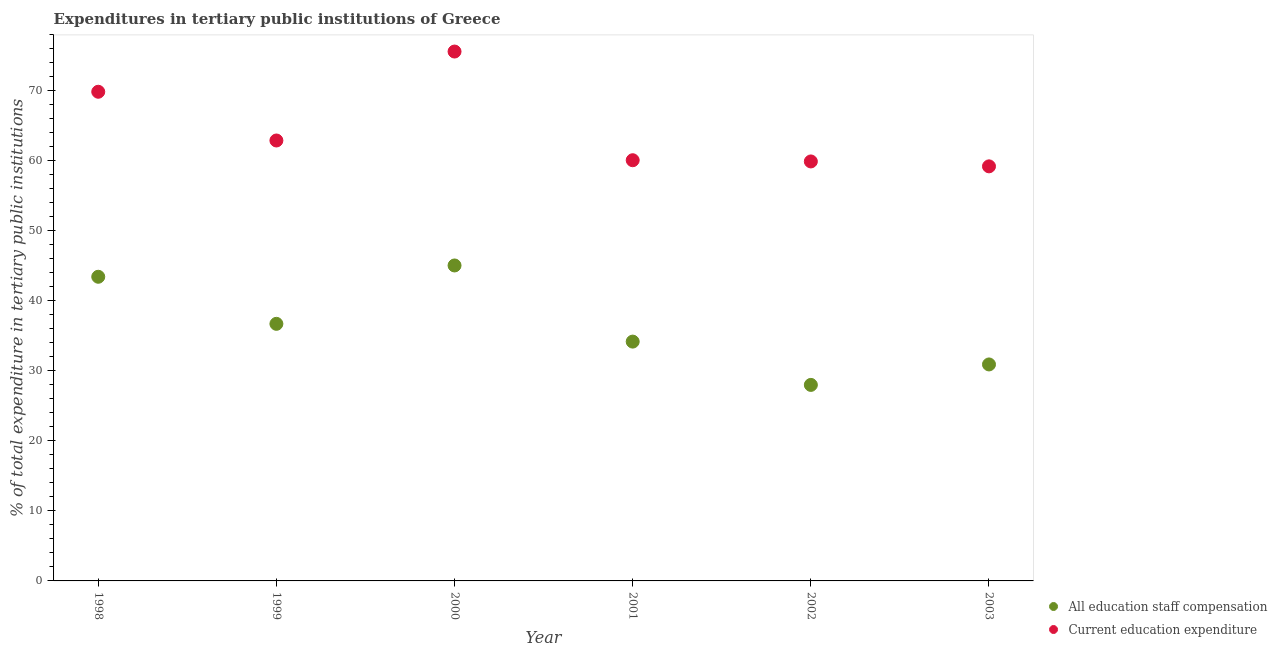What is the expenditure in education in 1998?
Keep it short and to the point. 69.88. Across all years, what is the maximum expenditure in education?
Give a very brief answer. 75.62. Across all years, what is the minimum expenditure in education?
Your response must be concise. 59.22. In which year was the expenditure in staff compensation maximum?
Make the answer very short. 2000. In which year was the expenditure in staff compensation minimum?
Offer a very short reply. 2002. What is the total expenditure in education in the graph?
Provide a succinct answer. 387.64. What is the difference between the expenditure in staff compensation in 1998 and that in 2003?
Make the answer very short. 12.52. What is the difference between the expenditure in education in 2003 and the expenditure in staff compensation in 2000?
Your response must be concise. 14.16. What is the average expenditure in staff compensation per year?
Give a very brief answer. 36.39. In the year 1998, what is the difference between the expenditure in staff compensation and expenditure in education?
Offer a very short reply. -26.43. In how many years, is the expenditure in education greater than 16 %?
Make the answer very short. 6. What is the ratio of the expenditure in staff compensation in 2000 to that in 2003?
Your answer should be very brief. 1.46. Is the expenditure in education in 1998 less than that in 1999?
Provide a succinct answer. No. What is the difference between the highest and the second highest expenditure in education?
Provide a short and direct response. 5.74. What is the difference between the highest and the lowest expenditure in education?
Offer a terse response. 16.4. In how many years, is the expenditure in education greater than the average expenditure in education taken over all years?
Your response must be concise. 2. Does the expenditure in staff compensation monotonically increase over the years?
Ensure brevity in your answer.  No. Is the expenditure in staff compensation strictly greater than the expenditure in education over the years?
Give a very brief answer. No. What is the difference between two consecutive major ticks on the Y-axis?
Offer a very short reply. 10. Are the values on the major ticks of Y-axis written in scientific E-notation?
Make the answer very short. No. Does the graph contain grids?
Your response must be concise. No. Where does the legend appear in the graph?
Your answer should be very brief. Bottom right. How many legend labels are there?
Give a very brief answer. 2. What is the title of the graph?
Make the answer very short. Expenditures in tertiary public institutions of Greece. Does "constant 2005 US$" appear as one of the legend labels in the graph?
Offer a terse response. No. What is the label or title of the X-axis?
Your answer should be very brief. Year. What is the label or title of the Y-axis?
Give a very brief answer. % of total expenditure in tertiary public institutions. What is the % of total expenditure in tertiary public institutions of All education staff compensation in 1998?
Offer a very short reply. 43.45. What is the % of total expenditure in tertiary public institutions of Current education expenditure in 1998?
Keep it short and to the point. 69.88. What is the % of total expenditure in tertiary public institutions of All education staff compensation in 1999?
Your answer should be compact. 36.72. What is the % of total expenditure in tertiary public institutions in Current education expenditure in 1999?
Your response must be concise. 62.91. What is the % of total expenditure in tertiary public institutions in All education staff compensation in 2000?
Ensure brevity in your answer.  45.06. What is the % of total expenditure in tertiary public institutions in Current education expenditure in 2000?
Provide a short and direct response. 75.62. What is the % of total expenditure in tertiary public institutions of All education staff compensation in 2001?
Make the answer very short. 34.19. What is the % of total expenditure in tertiary public institutions in Current education expenditure in 2001?
Provide a short and direct response. 60.09. What is the % of total expenditure in tertiary public institutions in All education staff compensation in 2002?
Provide a short and direct response. 28. What is the % of total expenditure in tertiary public institutions of Current education expenditure in 2002?
Give a very brief answer. 59.92. What is the % of total expenditure in tertiary public institutions of All education staff compensation in 2003?
Ensure brevity in your answer.  30.92. What is the % of total expenditure in tertiary public institutions of Current education expenditure in 2003?
Your response must be concise. 59.22. Across all years, what is the maximum % of total expenditure in tertiary public institutions in All education staff compensation?
Provide a succinct answer. 45.06. Across all years, what is the maximum % of total expenditure in tertiary public institutions of Current education expenditure?
Keep it short and to the point. 75.62. Across all years, what is the minimum % of total expenditure in tertiary public institutions of All education staff compensation?
Ensure brevity in your answer.  28. Across all years, what is the minimum % of total expenditure in tertiary public institutions of Current education expenditure?
Provide a succinct answer. 59.22. What is the total % of total expenditure in tertiary public institutions of All education staff compensation in the graph?
Provide a succinct answer. 218.34. What is the total % of total expenditure in tertiary public institutions of Current education expenditure in the graph?
Give a very brief answer. 387.64. What is the difference between the % of total expenditure in tertiary public institutions in All education staff compensation in 1998 and that in 1999?
Provide a short and direct response. 6.72. What is the difference between the % of total expenditure in tertiary public institutions in Current education expenditure in 1998 and that in 1999?
Make the answer very short. 6.96. What is the difference between the % of total expenditure in tertiary public institutions of All education staff compensation in 1998 and that in 2000?
Your answer should be very brief. -1.61. What is the difference between the % of total expenditure in tertiary public institutions of Current education expenditure in 1998 and that in 2000?
Keep it short and to the point. -5.74. What is the difference between the % of total expenditure in tertiary public institutions of All education staff compensation in 1998 and that in 2001?
Make the answer very short. 9.26. What is the difference between the % of total expenditure in tertiary public institutions of Current education expenditure in 1998 and that in 2001?
Keep it short and to the point. 9.78. What is the difference between the % of total expenditure in tertiary public institutions in All education staff compensation in 1998 and that in 2002?
Make the answer very short. 15.45. What is the difference between the % of total expenditure in tertiary public institutions in Current education expenditure in 1998 and that in 2002?
Your answer should be very brief. 9.95. What is the difference between the % of total expenditure in tertiary public institutions in All education staff compensation in 1998 and that in 2003?
Offer a very short reply. 12.52. What is the difference between the % of total expenditure in tertiary public institutions of Current education expenditure in 1998 and that in 2003?
Offer a very short reply. 10.65. What is the difference between the % of total expenditure in tertiary public institutions in All education staff compensation in 1999 and that in 2000?
Ensure brevity in your answer.  -8.34. What is the difference between the % of total expenditure in tertiary public institutions of Current education expenditure in 1999 and that in 2000?
Your answer should be very brief. -12.71. What is the difference between the % of total expenditure in tertiary public institutions of All education staff compensation in 1999 and that in 2001?
Your answer should be compact. 2.54. What is the difference between the % of total expenditure in tertiary public institutions in Current education expenditure in 1999 and that in 2001?
Offer a very short reply. 2.82. What is the difference between the % of total expenditure in tertiary public institutions in All education staff compensation in 1999 and that in 2002?
Give a very brief answer. 8.72. What is the difference between the % of total expenditure in tertiary public institutions of Current education expenditure in 1999 and that in 2002?
Your answer should be compact. 2.99. What is the difference between the % of total expenditure in tertiary public institutions in All education staff compensation in 1999 and that in 2003?
Give a very brief answer. 5.8. What is the difference between the % of total expenditure in tertiary public institutions in Current education expenditure in 1999 and that in 2003?
Your answer should be compact. 3.69. What is the difference between the % of total expenditure in tertiary public institutions of All education staff compensation in 2000 and that in 2001?
Your answer should be compact. 10.88. What is the difference between the % of total expenditure in tertiary public institutions of Current education expenditure in 2000 and that in 2001?
Provide a short and direct response. 15.53. What is the difference between the % of total expenditure in tertiary public institutions of All education staff compensation in 2000 and that in 2002?
Offer a terse response. 17.06. What is the difference between the % of total expenditure in tertiary public institutions in Current education expenditure in 2000 and that in 2002?
Provide a succinct answer. 15.7. What is the difference between the % of total expenditure in tertiary public institutions of All education staff compensation in 2000 and that in 2003?
Offer a terse response. 14.14. What is the difference between the % of total expenditure in tertiary public institutions of Current education expenditure in 2000 and that in 2003?
Ensure brevity in your answer.  16.4. What is the difference between the % of total expenditure in tertiary public institutions in All education staff compensation in 2001 and that in 2002?
Your answer should be very brief. 6.18. What is the difference between the % of total expenditure in tertiary public institutions of Current education expenditure in 2001 and that in 2002?
Provide a short and direct response. 0.17. What is the difference between the % of total expenditure in tertiary public institutions in All education staff compensation in 2001 and that in 2003?
Your response must be concise. 3.26. What is the difference between the % of total expenditure in tertiary public institutions in Current education expenditure in 2001 and that in 2003?
Your response must be concise. 0.87. What is the difference between the % of total expenditure in tertiary public institutions in All education staff compensation in 2002 and that in 2003?
Provide a succinct answer. -2.92. What is the difference between the % of total expenditure in tertiary public institutions in Current education expenditure in 2002 and that in 2003?
Your answer should be compact. 0.7. What is the difference between the % of total expenditure in tertiary public institutions of All education staff compensation in 1998 and the % of total expenditure in tertiary public institutions of Current education expenditure in 1999?
Offer a terse response. -19.47. What is the difference between the % of total expenditure in tertiary public institutions in All education staff compensation in 1998 and the % of total expenditure in tertiary public institutions in Current education expenditure in 2000?
Ensure brevity in your answer.  -32.17. What is the difference between the % of total expenditure in tertiary public institutions in All education staff compensation in 1998 and the % of total expenditure in tertiary public institutions in Current education expenditure in 2001?
Offer a terse response. -16.65. What is the difference between the % of total expenditure in tertiary public institutions in All education staff compensation in 1998 and the % of total expenditure in tertiary public institutions in Current education expenditure in 2002?
Give a very brief answer. -16.47. What is the difference between the % of total expenditure in tertiary public institutions of All education staff compensation in 1998 and the % of total expenditure in tertiary public institutions of Current education expenditure in 2003?
Your answer should be compact. -15.77. What is the difference between the % of total expenditure in tertiary public institutions of All education staff compensation in 1999 and the % of total expenditure in tertiary public institutions of Current education expenditure in 2000?
Offer a very short reply. -38.9. What is the difference between the % of total expenditure in tertiary public institutions in All education staff compensation in 1999 and the % of total expenditure in tertiary public institutions in Current education expenditure in 2001?
Your answer should be compact. -23.37. What is the difference between the % of total expenditure in tertiary public institutions of All education staff compensation in 1999 and the % of total expenditure in tertiary public institutions of Current education expenditure in 2002?
Offer a very short reply. -23.2. What is the difference between the % of total expenditure in tertiary public institutions of All education staff compensation in 1999 and the % of total expenditure in tertiary public institutions of Current education expenditure in 2003?
Make the answer very short. -22.5. What is the difference between the % of total expenditure in tertiary public institutions of All education staff compensation in 2000 and the % of total expenditure in tertiary public institutions of Current education expenditure in 2001?
Your answer should be very brief. -15.03. What is the difference between the % of total expenditure in tertiary public institutions in All education staff compensation in 2000 and the % of total expenditure in tertiary public institutions in Current education expenditure in 2002?
Provide a succinct answer. -14.86. What is the difference between the % of total expenditure in tertiary public institutions in All education staff compensation in 2000 and the % of total expenditure in tertiary public institutions in Current education expenditure in 2003?
Your answer should be very brief. -14.16. What is the difference between the % of total expenditure in tertiary public institutions in All education staff compensation in 2001 and the % of total expenditure in tertiary public institutions in Current education expenditure in 2002?
Ensure brevity in your answer.  -25.74. What is the difference between the % of total expenditure in tertiary public institutions of All education staff compensation in 2001 and the % of total expenditure in tertiary public institutions of Current education expenditure in 2003?
Provide a short and direct response. -25.03. What is the difference between the % of total expenditure in tertiary public institutions of All education staff compensation in 2002 and the % of total expenditure in tertiary public institutions of Current education expenditure in 2003?
Your answer should be compact. -31.22. What is the average % of total expenditure in tertiary public institutions in All education staff compensation per year?
Provide a short and direct response. 36.39. What is the average % of total expenditure in tertiary public institutions in Current education expenditure per year?
Offer a terse response. 64.61. In the year 1998, what is the difference between the % of total expenditure in tertiary public institutions in All education staff compensation and % of total expenditure in tertiary public institutions in Current education expenditure?
Your answer should be very brief. -26.43. In the year 1999, what is the difference between the % of total expenditure in tertiary public institutions in All education staff compensation and % of total expenditure in tertiary public institutions in Current education expenditure?
Offer a terse response. -26.19. In the year 2000, what is the difference between the % of total expenditure in tertiary public institutions in All education staff compensation and % of total expenditure in tertiary public institutions in Current education expenditure?
Provide a short and direct response. -30.56. In the year 2001, what is the difference between the % of total expenditure in tertiary public institutions of All education staff compensation and % of total expenditure in tertiary public institutions of Current education expenditure?
Keep it short and to the point. -25.91. In the year 2002, what is the difference between the % of total expenditure in tertiary public institutions in All education staff compensation and % of total expenditure in tertiary public institutions in Current education expenditure?
Offer a very short reply. -31.92. In the year 2003, what is the difference between the % of total expenditure in tertiary public institutions in All education staff compensation and % of total expenditure in tertiary public institutions in Current education expenditure?
Your response must be concise. -28.3. What is the ratio of the % of total expenditure in tertiary public institutions in All education staff compensation in 1998 to that in 1999?
Offer a terse response. 1.18. What is the ratio of the % of total expenditure in tertiary public institutions in Current education expenditure in 1998 to that in 1999?
Give a very brief answer. 1.11. What is the ratio of the % of total expenditure in tertiary public institutions in All education staff compensation in 1998 to that in 2000?
Give a very brief answer. 0.96. What is the ratio of the % of total expenditure in tertiary public institutions of Current education expenditure in 1998 to that in 2000?
Offer a very short reply. 0.92. What is the ratio of the % of total expenditure in tertiary public institutions of All education staff compensation in 1998 to that in 2001?
Your answer should be compact. 1.27. What is the ratio of the % of total expenditure in tertiary public institutions in Current education expenditure in 1998 to that in 2001?
Offer a terse response. 1.16. What is the ratio of the % of total expenditure in tertiary public institutions of All education staff compensation in 1998 to that in 2002?
Provide a succinct answer. 1.55. What is the ratio of the % of total expenditure in tertiary public institutions in Current education expenditure in 1998 to that in 2002?
Offer a very short reply. 1.17. What is the ratio of the % of total expenditure in tertiary public institutions of All education staff compensation in 1998 to that in 2003?
Your response must be concise. 1.41. What is the ratio of the % of total expenditure in tertiary public institutions in Current education expenditure in 1998 to that in 2003?
Your answer should be very brief. 1.18. What is the ratio of the % of total expenditure in tertiary public institutions of All education staff compensation in 1999 to that in 2000?
Your answer should be compact. 0.81. What is the ratio of the % of total expenditure in tertiary public institutions of Current education expenditure in 1999 to that in 2000?
Ensure brevity in your answer.  0.83. What is the ratio of the % of total expenditure in tertiary public institutions of All education staff compensation in 1999 to that in 2001?
Your response must be concise. 1.07. What is the ratio of the % of total expenditure in tertiary public institutions of Current education expenditure in 1999 to that in 2001?
Offer a very short reply. 1.05. What is the ratio of the % of total expenditure in tertiary public institutions in All education staff compensation in 1999 to that in 2002?
Make the answer very short. 1.31. What is the ratio of the % of total expenditure in tertiary public institutions in Current education expenditure in 1999 to that in 2002?
Offer a very short reply. 1.05. What is the ratio of the % of total expenditure in tertiary public institutions in All education staff compensation in 1999 to that in 2003?
Your answer should be compact. 1.19. What is the ratio of the % of total expenditure in tertiary public institutions in Current education expenditure in 1999 to that in 2003?
Ensure brevity in your answer.  1.06. What is the ratio of the % of total expenditure in tertiary public institutions in All education staff compensation in 2000 to that in 2001?
Ensure brevity in your answer.  1.32. What is the ratio of the % of total expenditure in tertiary public institutions in Current education expenditure in 2000 to that in 2001?
Offer a very short reply. 1.26. What is the ratio of the % of total expenditure in tertiary public institutions in All education staff compensation in 2000 to that in 2002?
Make the answer very short. 1.61. What is the ratio of the % of total expenditure in tertiary public institutions of Current education expenditure in 2000 to that in 2002?
Your response must be concise. 1.26. What is the ratio of the % of total expenditure in tertiary public institutions of All education staff compensation in 2000 to that in 2003?
Offer a very short reply. 1.46. What is the ratio of the % of total expenditure in tertiary public institutions in Current education expenditure in 2000 to that in 2003?
Your answer should be compact. 1.28. What is the ratio of the % of total expenditure in tertiary public institutions of All education staff compensation in 2001 to that in 2002?
Provide a short and direct response. 1.22. What is the ratio of the % of total expenditure in tertiary public institutions of All education staff compensation in 2001 to that in 2003?
Provide a short and direct response. 1.11. What is the ratio of the % of total expenditure in tertiary public institutions of Current education expenditure in 2001 to that in 2003?
Your answer should be compact. 1.01. What is the ratio of the % of total expenditure in tertiary public institutions of All education staff compensation in 2002 to that in 2003?
Keep it short and to the point. 0.91. What is the ratio of the % of total expenditure in tertiary public institutions of Current education expenditure in 2002 to that in 2003?
Ensure brevity in your answer.  1.01. What is the difference between the highest and the second highest % of total expenditure in tertiary public institutions of All education staff compensation?
Offer a very short reply. 1.61. What is the difference between the highest and the second highest % of total expenditure in tertiary public institutions in Current education expenditure?
Your response must be concise. 5.74. What is the difference between the highest and the lowest % of total expenditure in tertiary public institutions of All education staff compensation?
Give a very brief answer. 17.06. What is the difference between the highest and the lowest % of total expenditure in tertiary public institutions in Current education expenditure?
Keep it short and to the point. 16.4. 